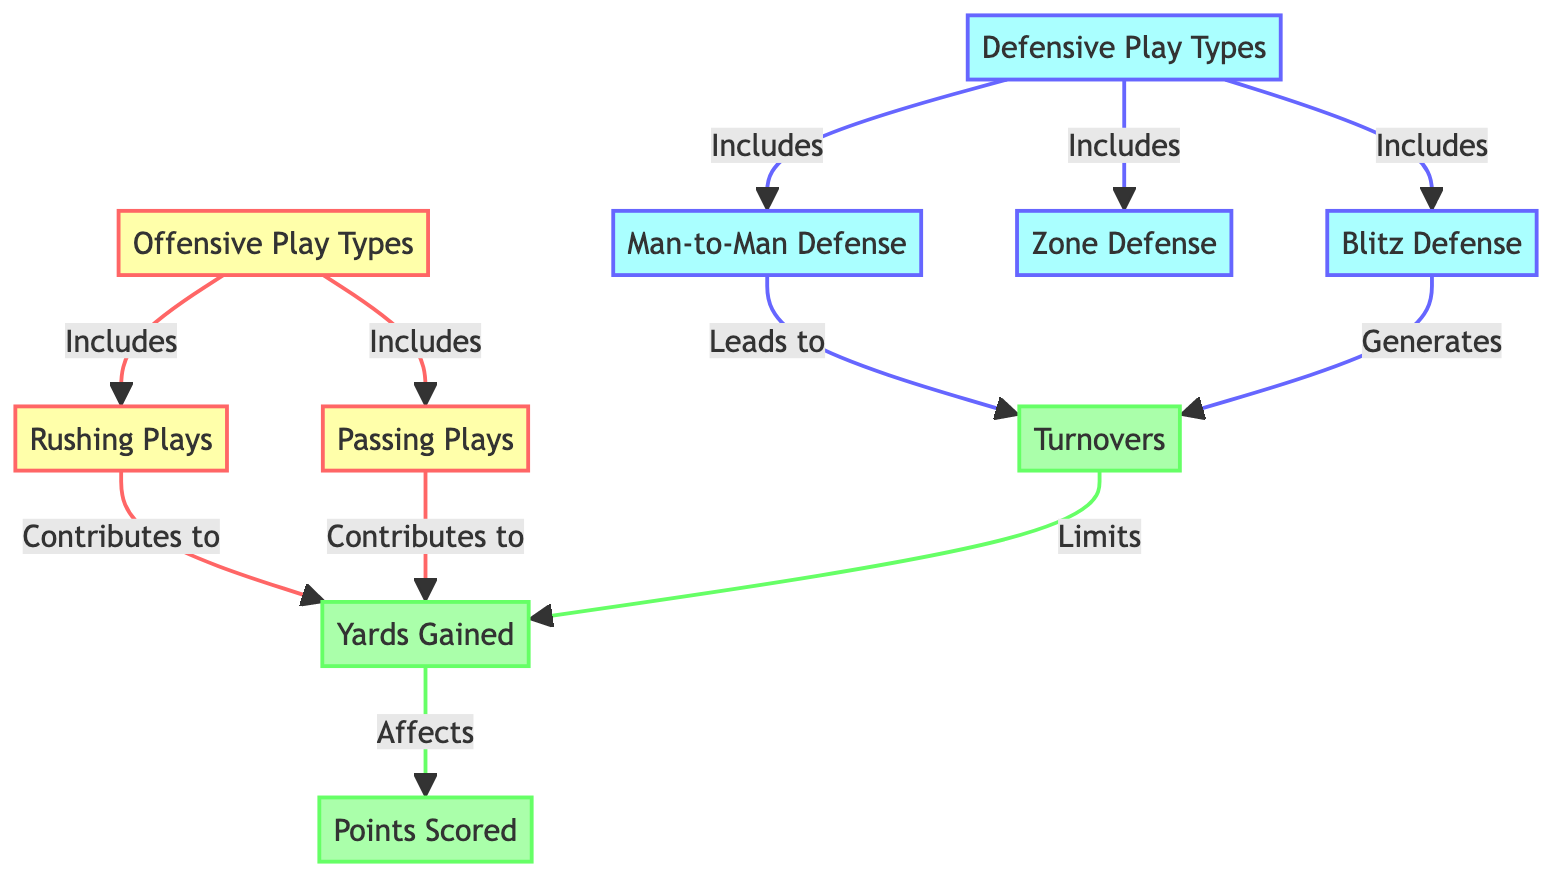What's included in Offensive Play Types? The diagram shows that Offensive Play Types include Rushing Plays and Passing Plays, as indicated by the connections from the node labeled "Offensive Play Types" to the other two nodes.
Answer: Rushing Plays, Passing Plays How many types of Defensive Plays are present in the diagram? By examining the node labeled "Defensive Play Types," we observe that there are three connected nodes: Blitz Defense, Zone Defense, and Man-to-Man Defense. Thus, we can conclude there are three types.
Answer: 3 What do Rushing Plays contribute to? The Rushing Plays node points to Yards Gained, indicating that Rushing Plays have a direct connection that contributes to the total Yards Gained during offensive plays.
Answer: Yards Gained How does Man-to-Man Defense lead to Turnovers? The diagram indicates a directed connection from Man-to-Man Defense to Turnovers. This suggests that the strategy employed in Man-to-Man Defense inherently leads to gaining possession of the ball from the opposing team.
Answer: Turnovers What is affected by Yards Gained? According to the diagram, the Yards Gained directly affects Points Scored, as shown by the arrow leading from Yards Gained to Points Scored. This implies that as Yards Gained increases, the potential for scoring points improves.
Answer: Points Scored If a team successfully executes a Blitz Defense, what is generated as a result? The diagram specifically indicates that Blitz Defense generates Turnovers, showing a causal relationship that highlights how this defensive strategy aims to create opportunities for the defense to regain possession of the ball.
Answer: Turnovers How many total connections (edges) are indicated in the diagram? By counting the directed connections among all nodes in the diagram, we find that there are eight distinct relationships indicated.
Answer: 8 Which play type leads to limiting Yards Gained? The diagram shows that both Blitz Defense and Turnovers lead to limiting Yards Gained, as both types are connected to this concept. However, Turnovers is the distinct lead connection as a consequence of defensive play.
Answer: Turnovers 